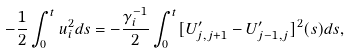Convert formula to latex. <formula><loc_0><loc_0><loc_500><loc_500>- \frac { 1 } { 2 } \int _ { 0 } ^ { t } u _ { i } ^ { 2 } d s = - \frac { \gamma _ { i } ^ { - 1 } } { 2 } \int _ { 0 } ^ { t } [ U ^ { \prime } _ { j , j + 1 } - U ^ { \prime } _ { j - 1 , j } ] ^ { 2 } ( s ) d s ,</formula> 